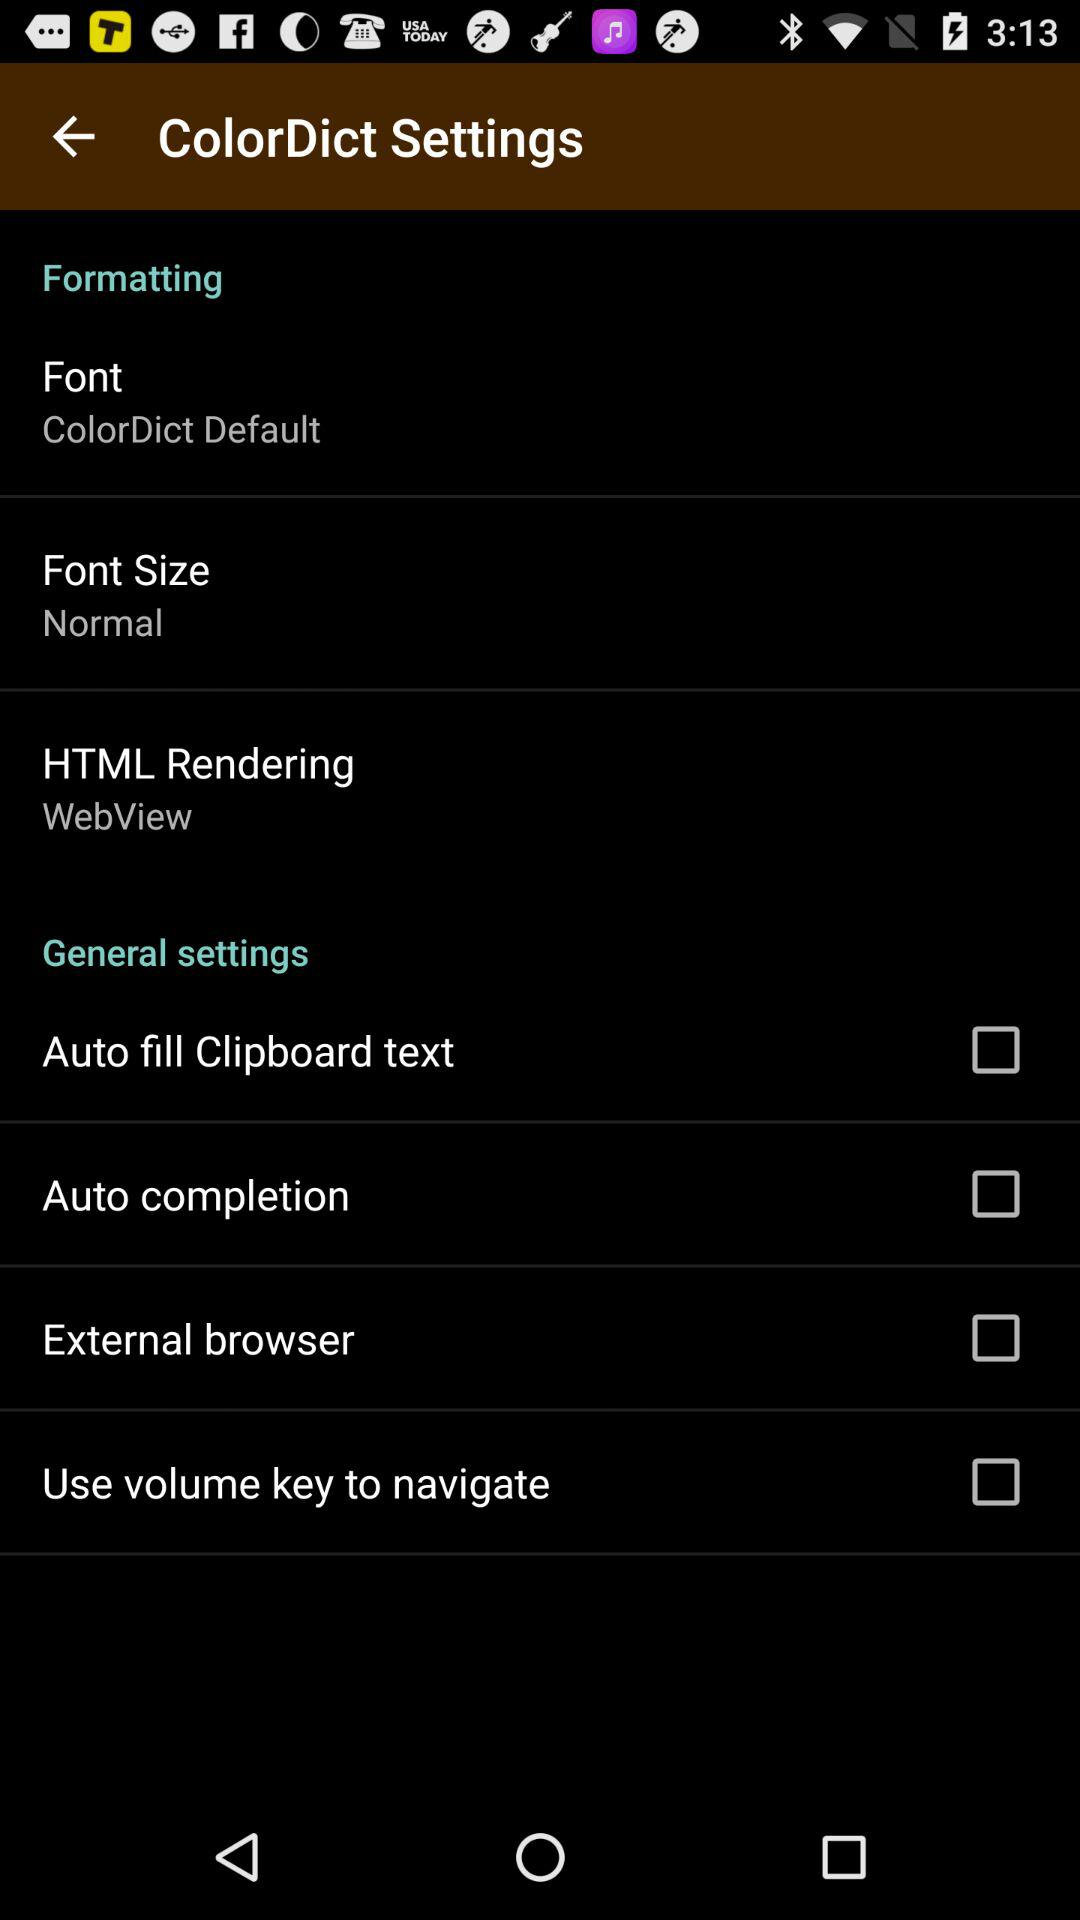What is the status of the "External browser"? The status is "off". 